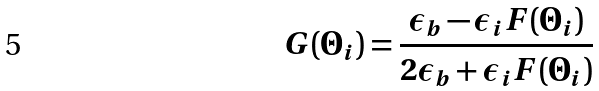Convert formula to latex. <formula><loc_0><loc_0><loc_500><loc_500>G ( \Theta _ { i } ) = \frac { \epsilon _ { b } - \epsilon _ { i } F ( \Theta _ { i } ) } { 2 \epsilon _ { b } + \epsilon _ { i } F ( \Theta _ { i } ) }</formula> 